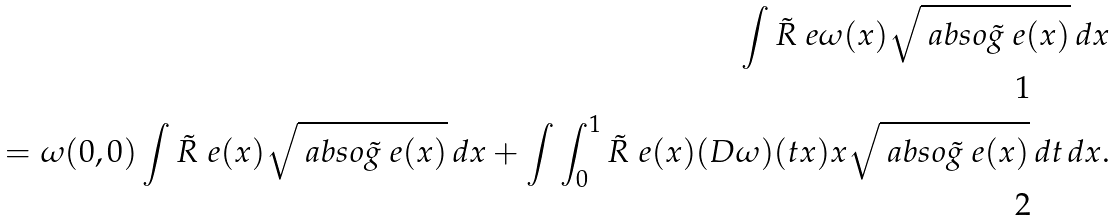Convert formula to latex. <formula><loc_0><loc_0><loc_500><loc_500>\int \tilde { R } _ { \ } e \omega ( x ) \sqrt { \ a b s o { \tilde { g } _ { \ } e ( x ) } } \, d x \\ = \omega ( 0 , 0 ) \int \tilde { R } _ { \ } e ( x ) \sqrt { \ a b s o { \tilde { g } _ { \ } e ( x ) } } \, d x + \int \int _ { 0 } ^ { 1 } \tilde { R } _ { \ } e ( x ) ( D \omega ) ( t x ) x \sqrt { \ a b s o { \tilde { g } _ { \ } e ( x ) } } \, d t \, d x .</formula> 